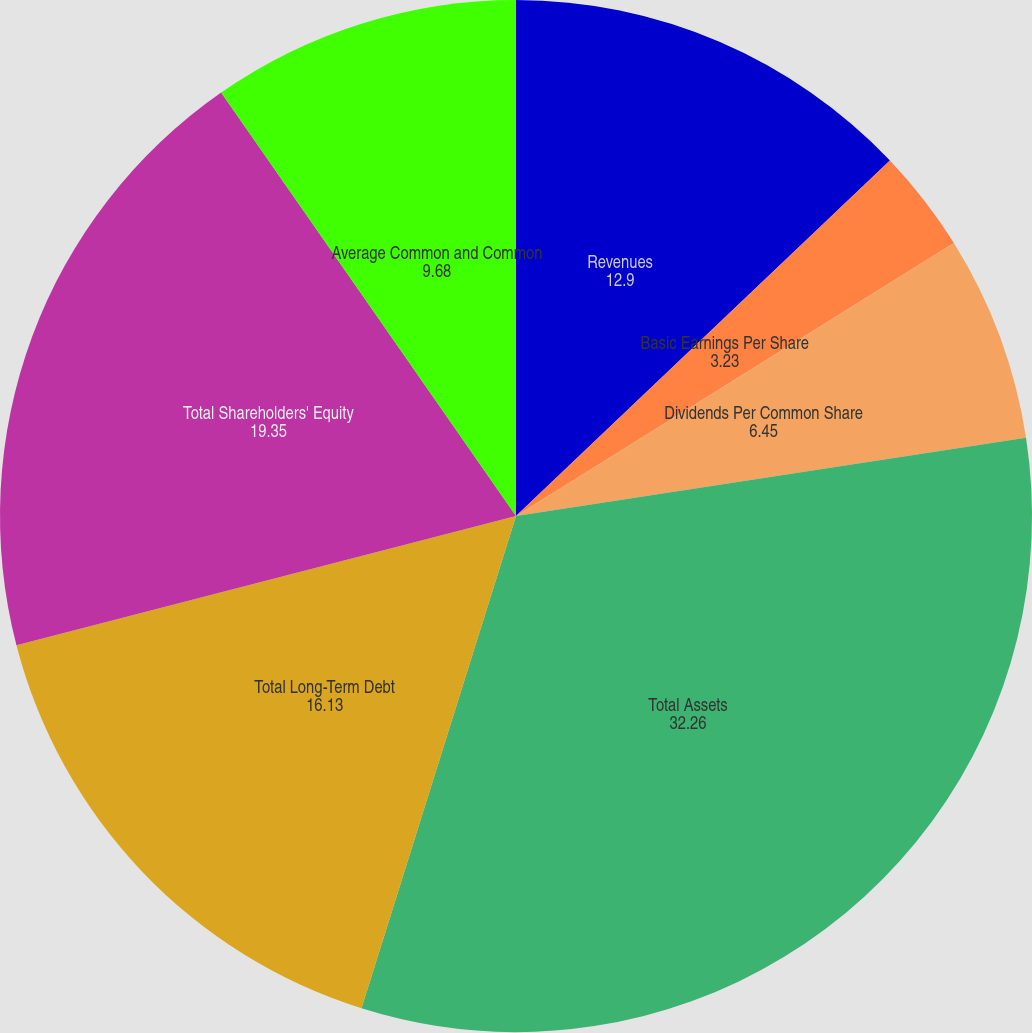Convert chart. <chart><loc_0><loc_0><loc_500><loc_500><pie_chart><fcel>Revenues<fcel>Basic Earnings Per Share<fcel>Diluted Earnings Per Share<fcel>Dividends Per Common Share<fcel>Total Assets<fcel>Total Long-Term Debt<fcel>Total Shareholders' Equity<fcel>Average Common and Common<nl><fcel>12.9%<fcel>3.23%<fcel>0.0%<fcel>6.45%<fcel>32.26%<fcel>16.13%<fcel>19.35%<fcel>9.68%<nl></chart> 